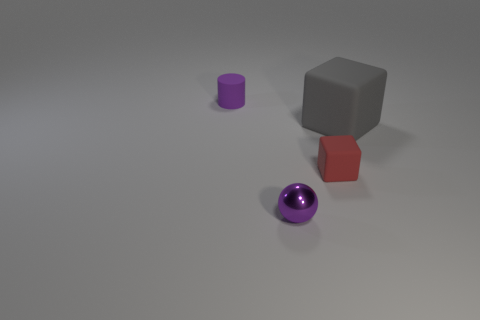What is the shape of the purple object that is the same size as the metallic ball?
Provide a short and direct response. Cylinder. Are the small purple sphere and the purple object that is behind the shiny sphere made of the same material?
Your answer should be very brief. No. What is the color of the small rubber object right of the purple object on the right side of the thing left of the purple shiny sphere?
Your response must be concise. Red. What is the material of the cylinder that is the same size as the purple ball?
Offer a very short reply. Rubber. What number of tiny spheres are the same material as the small purple cylinder?
Keep it short and to the point. 0. Do the matte object right of the red rubber block and the object that is on the left side of the purple metal object have the same size?
Make the answer very short. No. What color is the small object to the right of the tiny metallic sphere?
Make the answer very short. Red. What is the material of the tiny thing that is the same color as the sphere?
Provide a short and direct response. Rubber. What number of cylinders are the same color as the ball?
Ensure brevity in your answer.  1. There is a sphere; is it the same size as the purple object that is left of the small purple ball?
Offer a very short reply. Yes. 